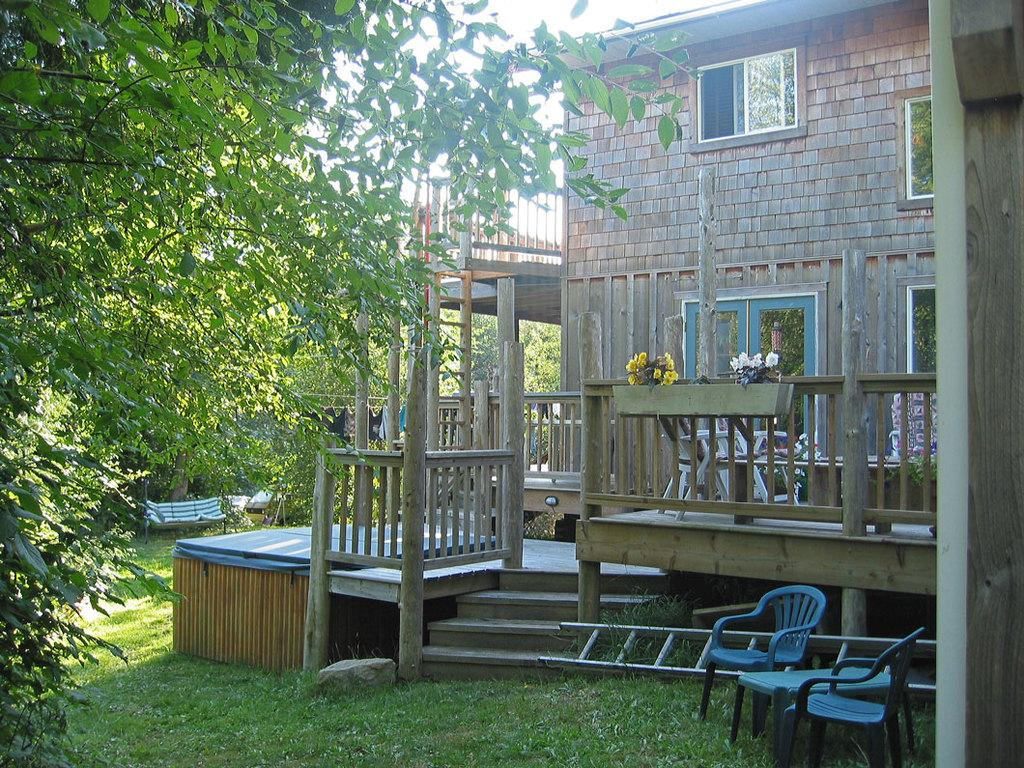What type of vegetation can be seen in the image? There is grass, plants, flowers, and trees in the image. What type of seating is present in the image? There are chairs and a bench in the image. What is the tall structure in the image used for? The ladder in the image is used for reaching higher places. What type of structure is visible in the background of the image? There is a building in the image. What is visible in the sky in the background of the image? The sky is visible in the background of the image. What is the tax rate for the school in the image? There is no school or tax rate mentioned in the image. What type of jam is being served on the bench in the image? There is no jam or serving of any food in the image. 